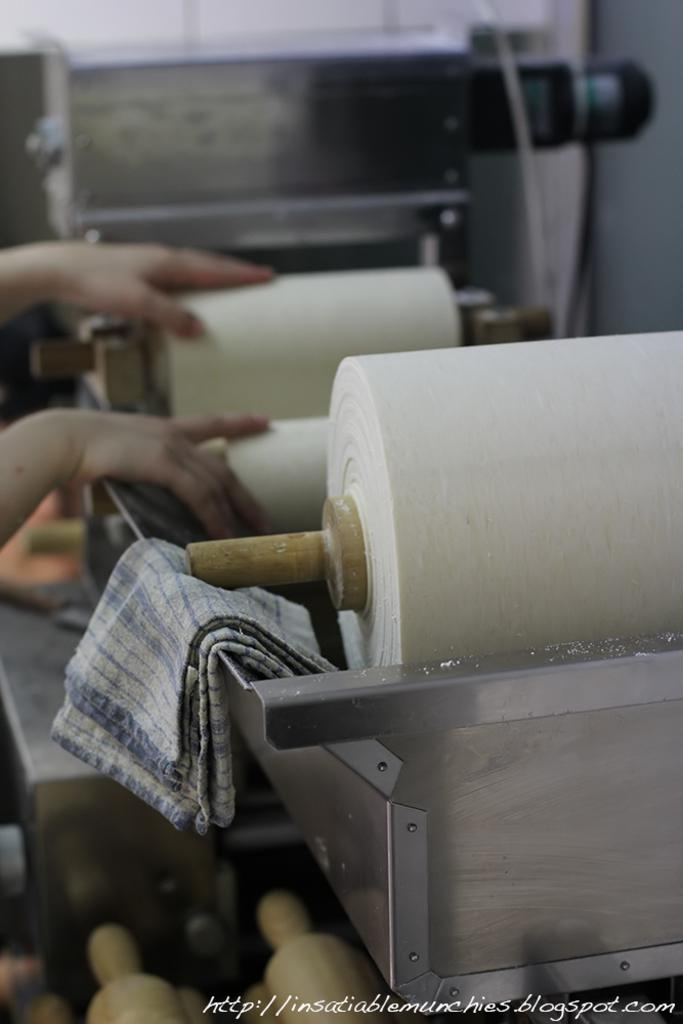What is being operated in the image? There are hands on a rolling machine in the image. What else can be seen in the image besides the rolling machine? There is a cloth in the image. Is there any text present in the image? Yes, there is some text at the bottom of the image. Where is the bed located in the image? There is no bed present in the image. What type of copy is being made on the rolling machine? The image does not show any copying or duplication process; it only shows hands operating a rolling machine. 